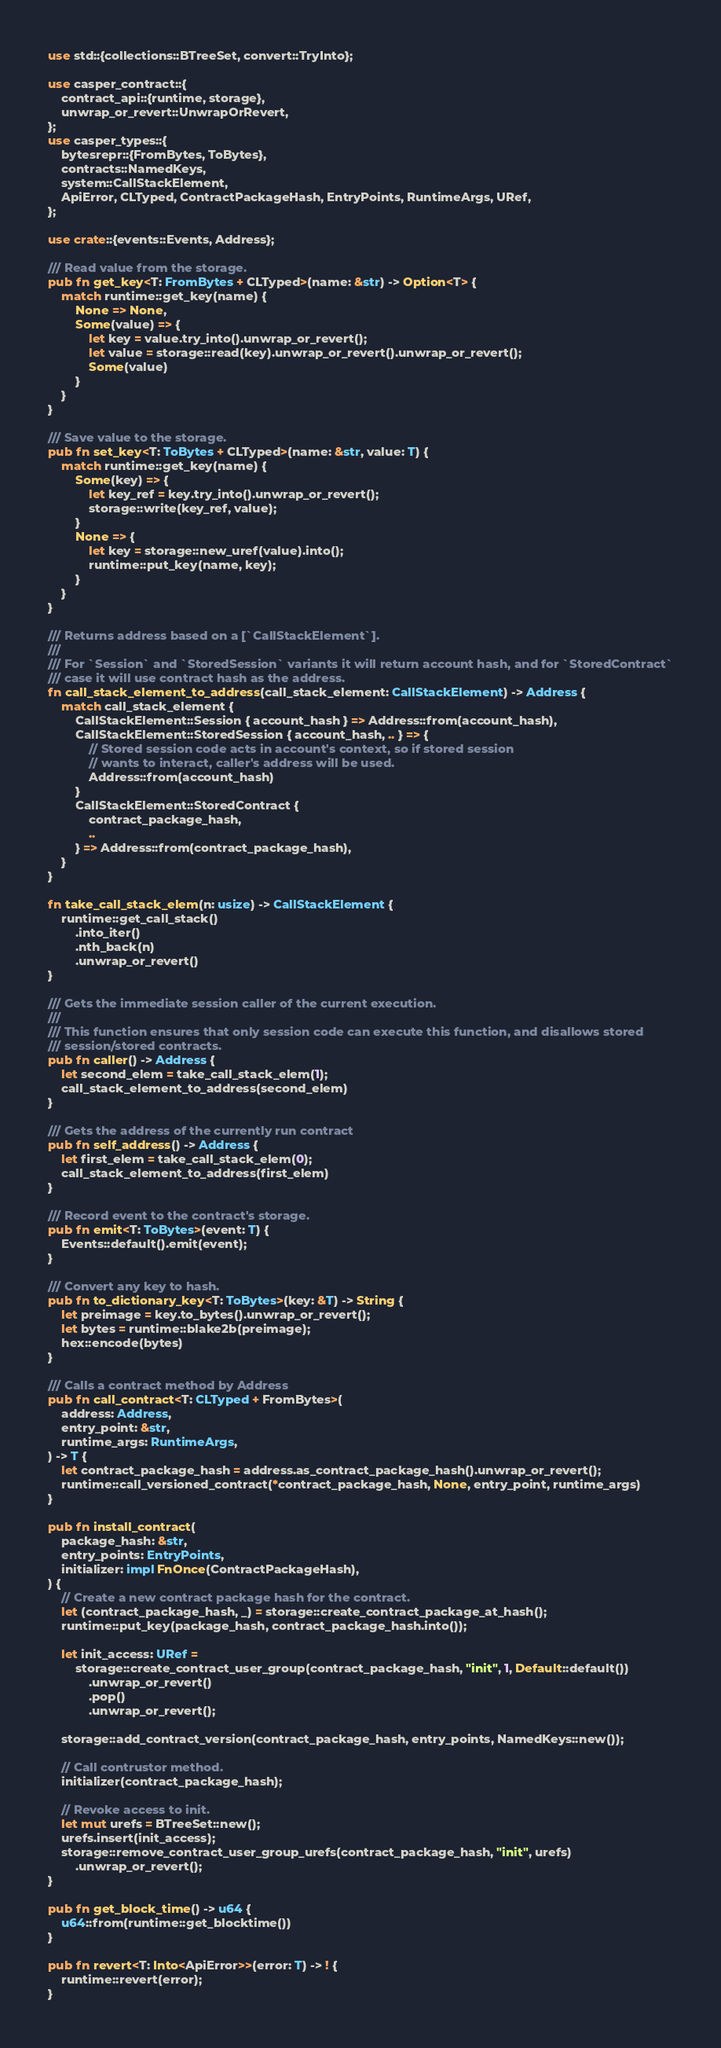<code> <loc_0><loc_0><loc_500><loc_500><_Rust_>use std::{collections::BTreeSet, convert::TryInto};

use casper_contract::{
    contract_api::{runtime, storage},
    unwrap_or_revert::UnwrapOrRevert,
};
use casper_types::{
    bytesrepr::{FromBytes, ToBytes},
    contracts::NamedKeys,
    system::CallStackElement,
    ApiError, CLTyped, ContractPackageHash, EntryPoints, RuntimeArgs, URef,
};

use crate::{events::Events, Address};

/// Read value from the storage.
pub fn get_key<T: FromBytes + CLTyped>(name: &str) -> Option<T> {
    match runtime::get_key(name) {
        None => None,
        Some(value) => {
            let key = value.try_into().unwrap_or_revert();
            let value = storage::read(key).unwrap_or_revert().unwrap_or_revert();
            Some(value)
        }
    }
}

/// Save value to the storage.
pub fn set_key<T: ToBytes + CLTyped>(name: &str, value: T) {
    match runtime::get_key(name) {
        Some(key) => {
            let key_ref = key.try_into().unwrap_or_revert();
            storage::write(key_ref, value);
        }
        None => {
            let key = storage::new_uref(value).into();
            runtime::put_key(name, key);
        }
    }
}

/// Returns address based on a [`CallStackElement`].
///
/// For `Session` and `StoredSession` variants it will return account hash, and for `StoredContract`
/// case it will use contract hash as the address.
fn call_stack_element_to_address(call_stack_element: CallStackElement) -> Address {
    match call_stack_element {
        CallStackElement::Session { account_hash } => Address::from(account_hash),
        CallStackElement::StoredSession { account_hash, .. } => {
            // Stored session code acts in account's context, so if stored session
            // wants to interact, caller's address will be used.
            Address::from(account_hash)
        }
        CallStackElement::StoredContract {
            contract_package_hash,
            ..
        } => Address::from(contract_package_hash),
    }
}

fn take_call_stack_elem(n: usize) -> CallStackElement {
    runtime::get_call_stack()
        .into_iter()
        .nth_back(n)
        .unwrap_or_revert()
}

/// Gets the immediate session caller of the current execution.
///
/// This function ensures that only session code can execute this function, and disallows stored
/// session/stored contracts.
pub fn caller() -> Address {
    let second_elem = take_call_stack_elem(1);
    call_stack_element_to_address(second_elem)
}

/// Gets the address of the currently run contract
pub fn self_address() -> Address {
    let first_elem = take_call_stack_elem(0);
    call_stack_element_to_address(first_elem)
}

/// Record event to the contract's storage.
pub fn emit<T: ToBytes>(event: T) {
    Events::default().emit(event);
}

/// Convert any key to hash.
pub fn to_dictionary_key<T: ToBytes>(key: &T) -> String {
    let preimage = key.to_bytes().unwrap_or_revert();
    let bytes = runtime::blake2b(preimage);
    hex::encode(bytes)
}

/// Calls a contract method by Address
pub fn call_contract<T: CLTyped + FromBytes>(
    address: Address,
    entry_point: &str,
    runtime_args: RuntimeArgs,
) -> T {
    let contract_package_hash = address.as_contract_package_hash().unwrap_or_revert();
    runtime::call_versioned_contract(*contract_package_hash, None, entry_point, runtime_args)
}

pub fn install_contract(
    package_hash: &str,
    entry_points: EntryPoints,
    initializer: impl FnOnce(ContractPackageHash),
) {
    // Create a new contract package hash for the contract.
    let (contract_package_hash, _) = storage::create_contract_package_at_hash();
    runtime::put_key(package_hash, contract_package_hash.into());

    let init_access: URef =
        storage::create_contract_user_group(contract_package_hash, "init", 1, Default::default())
            .unwrap_or_revert()
            .pop()
            .unwrap_or_revert();

    storage::add_contract_version(contract_package_hash, entry_points, NamedKeys::new());

    // Call contrustor method.
    initializer(contract_package_hash);

    // Revoke access to init.
    let mut urefs = BTreeSet::new();
    urefs.insert(init_access);
    storage::remove_contract_user_group_urefs(contract_package_hash, "init", urefs)
        .unwrap_or_revert();
}

pub fn get_block_time() -> u64 {
    u64::from(runtime::get_blocktime())
}

pub fn revert<T: Into<ApiError>>(error: T) -> ! {
    runtime::revert(error);
}
</code> 